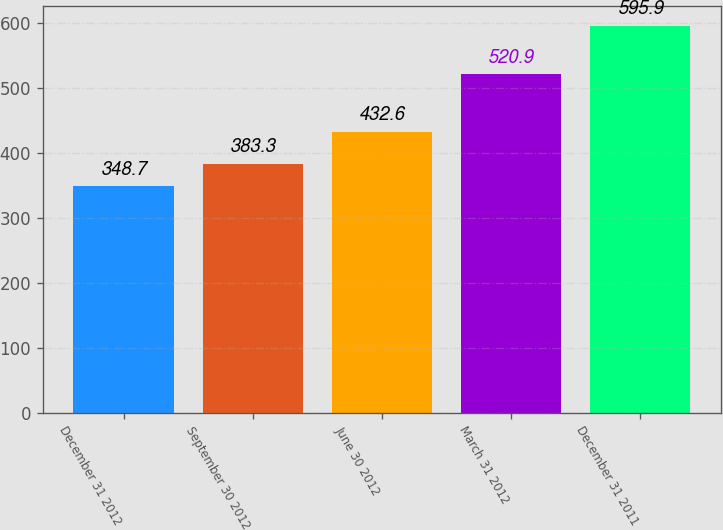<chart> <loc_0><loc_0><loc_500><loc_500><bar_chart><fcel>December 31 2012<fcel>September 30 2012<fcel>June 30 2012<fcel>March 31 2012<fcel>December 31 2011<nl><fcel>348.7<fcel>383.3<fcel>432.6<fcel>520.9<fcel>595.9<nl></chart> 